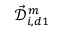Convert formula to latex. <formula><loc_0><loc_0><loc_500><loc_500>\mathcal { \vec { D } } _ { i , d 1 } ^ { m }</formula> 